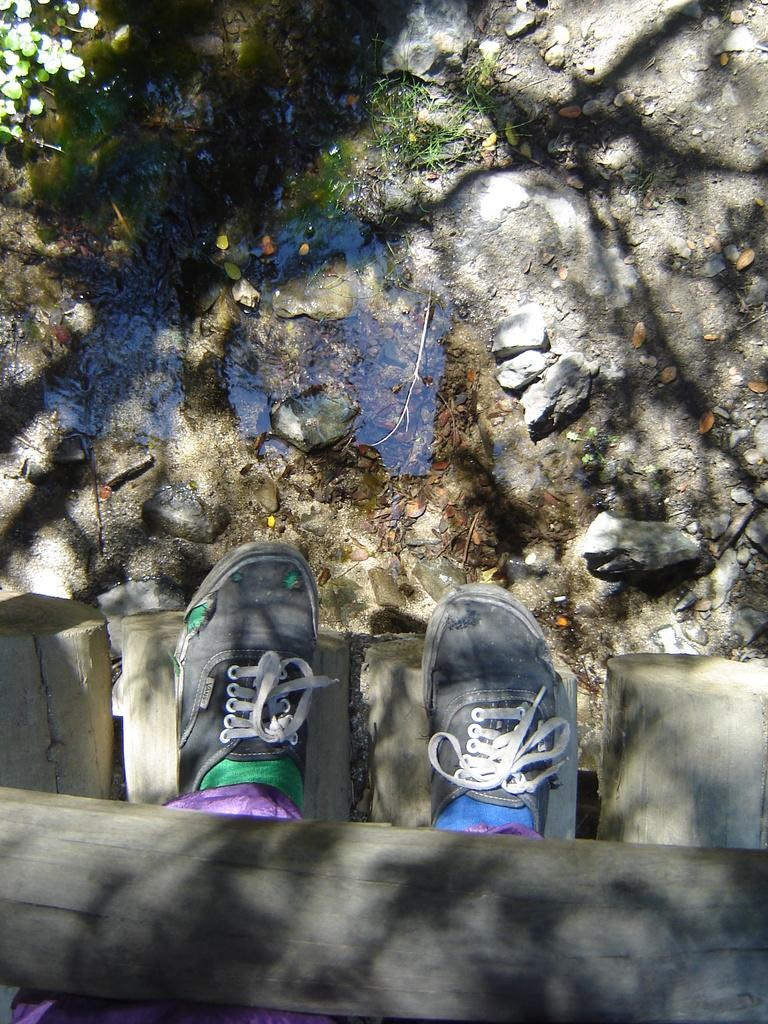What part of a person can be seen in the image? There are legs of a person visible in the image. What type of footwear is the person wearing? The person is wearing shoes. What type of natural elements can be seen in the background of the image? There are stones and water visible in the background of the image. What type of produce is being harvested in the image? There is no produce visible in the image. How much honey can be seen dripping from the person's shoes in the image? There is no honey present in the image. 